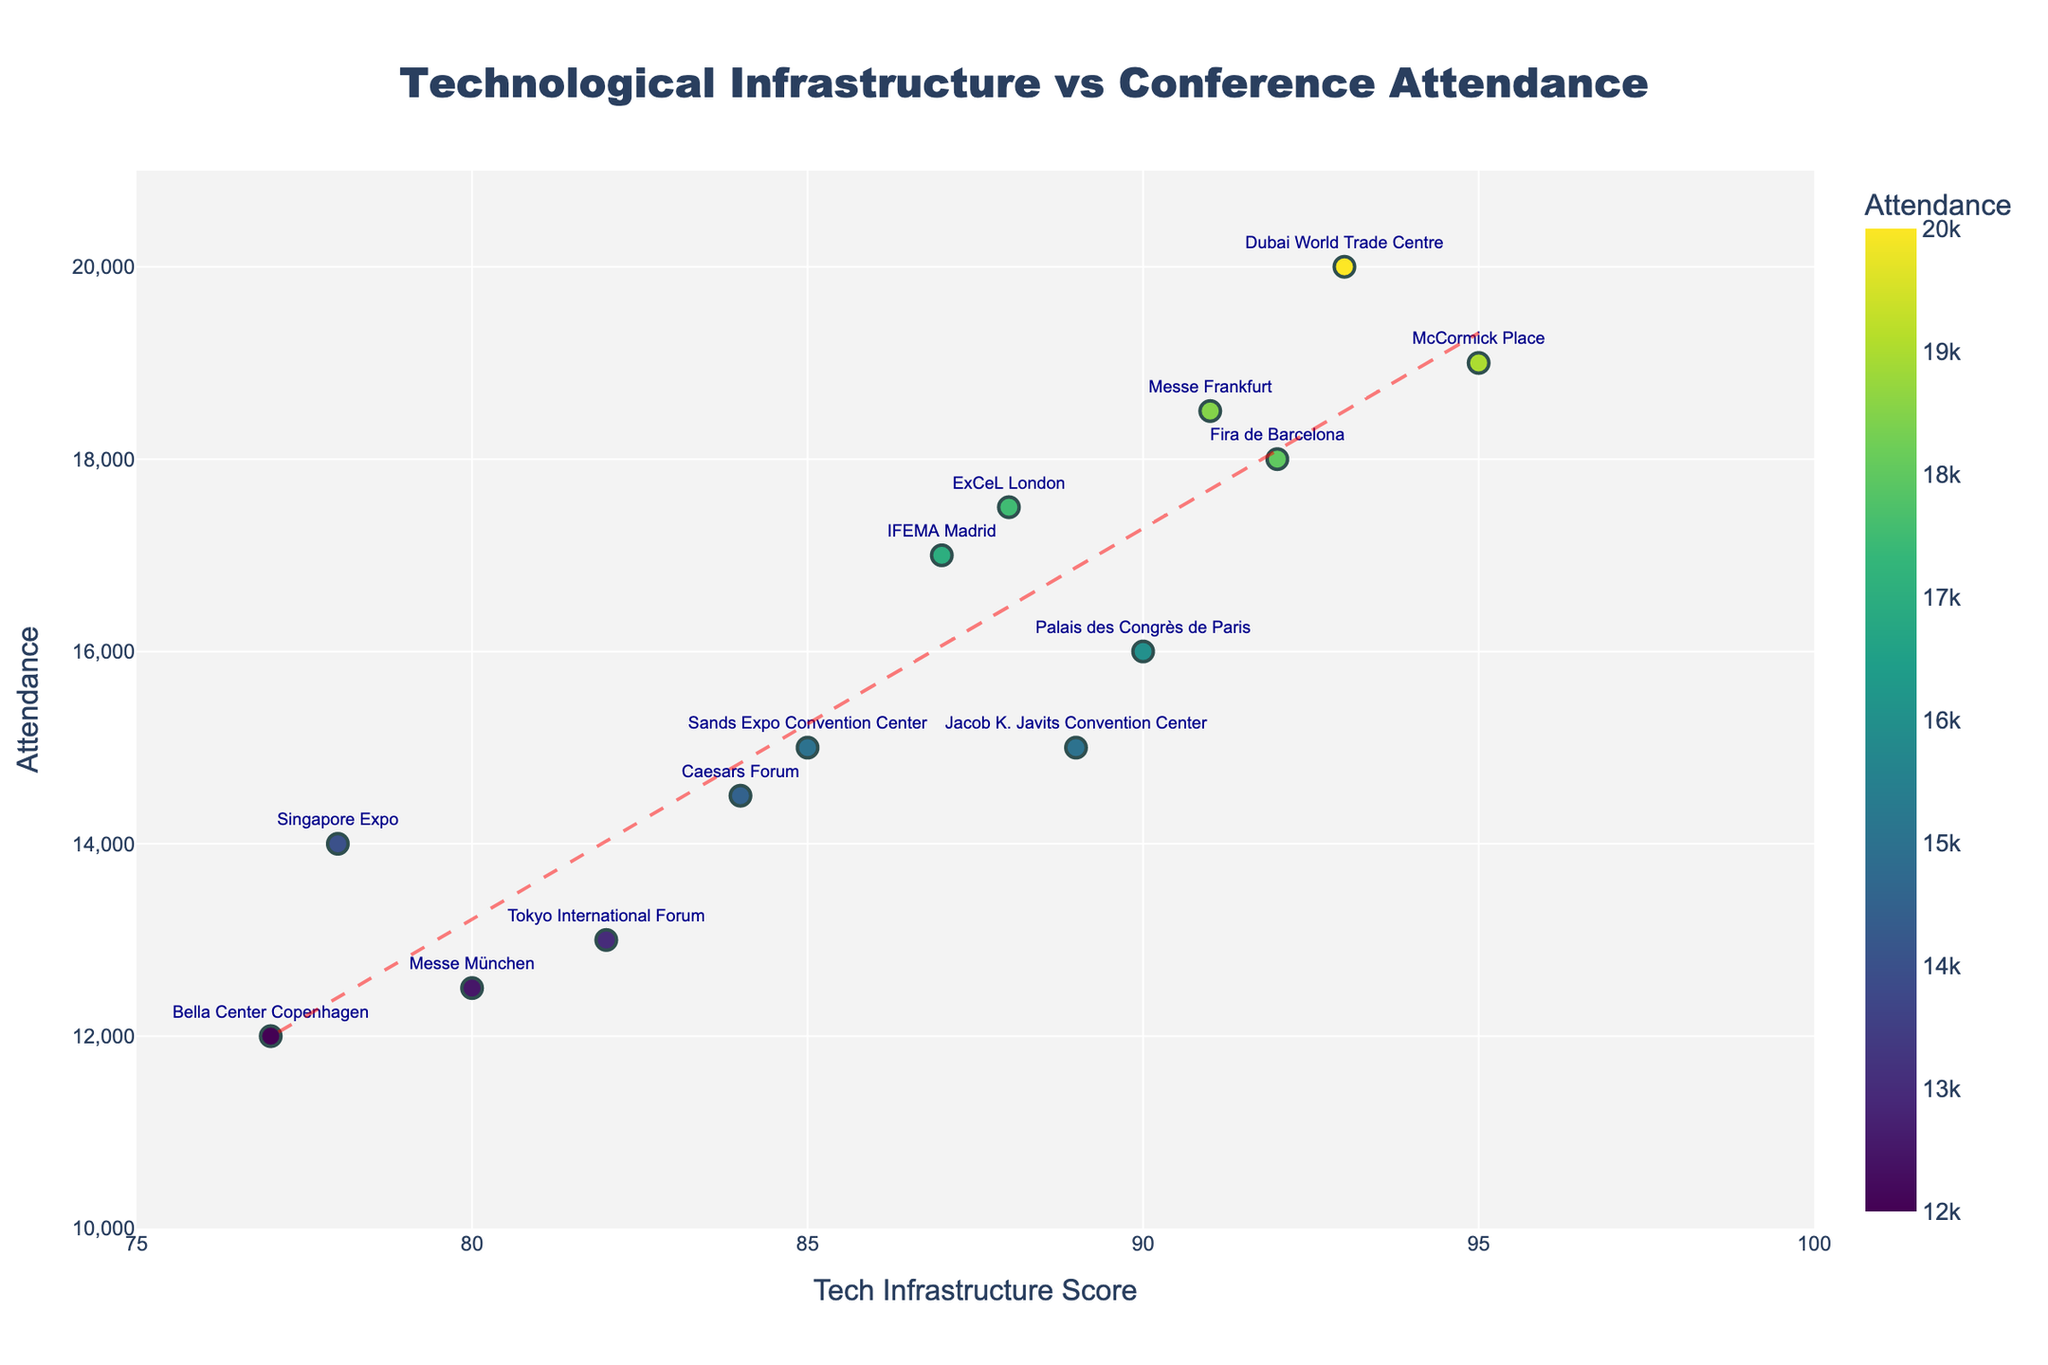what is the title of the plot? The title is located at the top center of the plot. It provides an overview of the data being presented.
Answer: Technological Infrastructure vs Conference Attendance What is the range of the x-axis? The x-axis represents the Technological Infrastructure Score. By observing the plot, we see that the values range from 75 to 100.
Answer: 75 to 100 Which venue has the highest Conference Attendance? By looking at the y-axis and the data points, we see that the Dubai World Trade Centre has the highest Conference Attendance at 20000.
Answer: Dubai World Trade Centre What color represents the highest Conference Attendance? The color of the data points indicates the Conference Attendance, with a color gradient. By identifying the marker representing the highest attendance, we see it is represented by a color from the Viridis scale, likely yellow.
Answer: Yellow How many data points are on the plot? Each data point corresponds to a venue. Counting the distinct points in the scatter plot, we find there are 14 points.
Answer: 14 Which two venues have the closest Tech Infrastructure Scores? Observing the scatter points, the closest Tech Infrastructure Scores are for ExCeL London (88) and IFEMA Madrid (87), separated only by 1 point.
Answer: ExCeL London and IFEMA Madrid What is the trend observed between Technological Infrastructure Score and Conference Attendance? The trend line indicates the relationship between the Tech Infrastructure Score and Conference Attendance. The line shows a positive slope, indicating that higher Tech Infrastructure Scores are generally associated with higher conference attendances.
Answer: Positive correlation How does the McCormick Place compare to Palais des Congrès de Paris in terms of Conference Attendance? McCormick Place has about 3000 more attendees compared to Palais des Congrès de Paris. McCormick Place has an attendance of 19000, while Palais des Congrès de Paris has 16000.
Answer: McCormick Place has about 3000 more attendees What is the average Conference Attendance across all venues? To find the average attendance, sum all attendance values and divide by the number of venues. Sum = 215000 (sum of all data points on y-axis), Number of venues = 14, Average = 215000 / 14 = 15357.
Answer: 15357 Which venue has the lowest Tech Infrastructure Score and what is its Conference Attendance? By identifying the lowest point on the x-axis, we see that Bella Center Copenhagen has the lowest Tech Infrastructure Score of 77 and its Conference Attendance is 12000.
Answer: Bella Center Copenhagen, 12000 